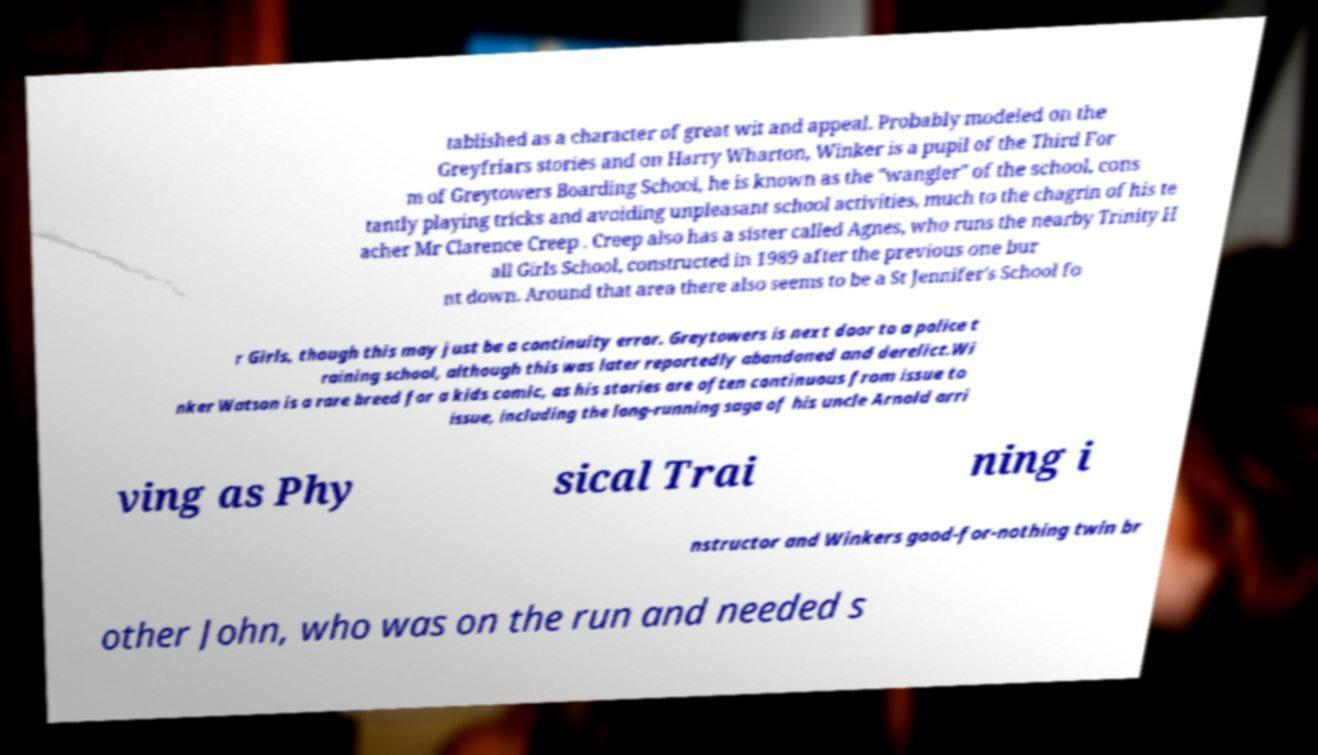Can you accurately transcribe the text from the provided image for me? tablished as a character of great wit and appeal. Probably modeled on the Greyfriars stories and on Harry Wharton, Winker is a pupil of the Third For m of Greytowers Boarding School, he is known as the "wangler" of the school, cons tantly playing tricks and avoiding unpleasant school activities, much to the chagrin of his te acher Mr Clarence Creep . Creep also has a sister called Agnes, who runs the nearby Trinity H all Girls School, constructed in 1989 after the previous one bur nt down. Around that area there also seems to be a St Jennifer's School fo r Girls, though this may just be a continuity error. Greytowers is next door to a police t raining school, although this was later reportedly abandoned and derelict.Wi nker Watson is a rare breed for a kids comic, as his stories are often continuous from issue to issue, including the long-running saga of his uncle Arnold arri ving as Phy sical Trai ning i nstructor and Winkers good-for-nothing twin br other John, who was on the run and needed s 